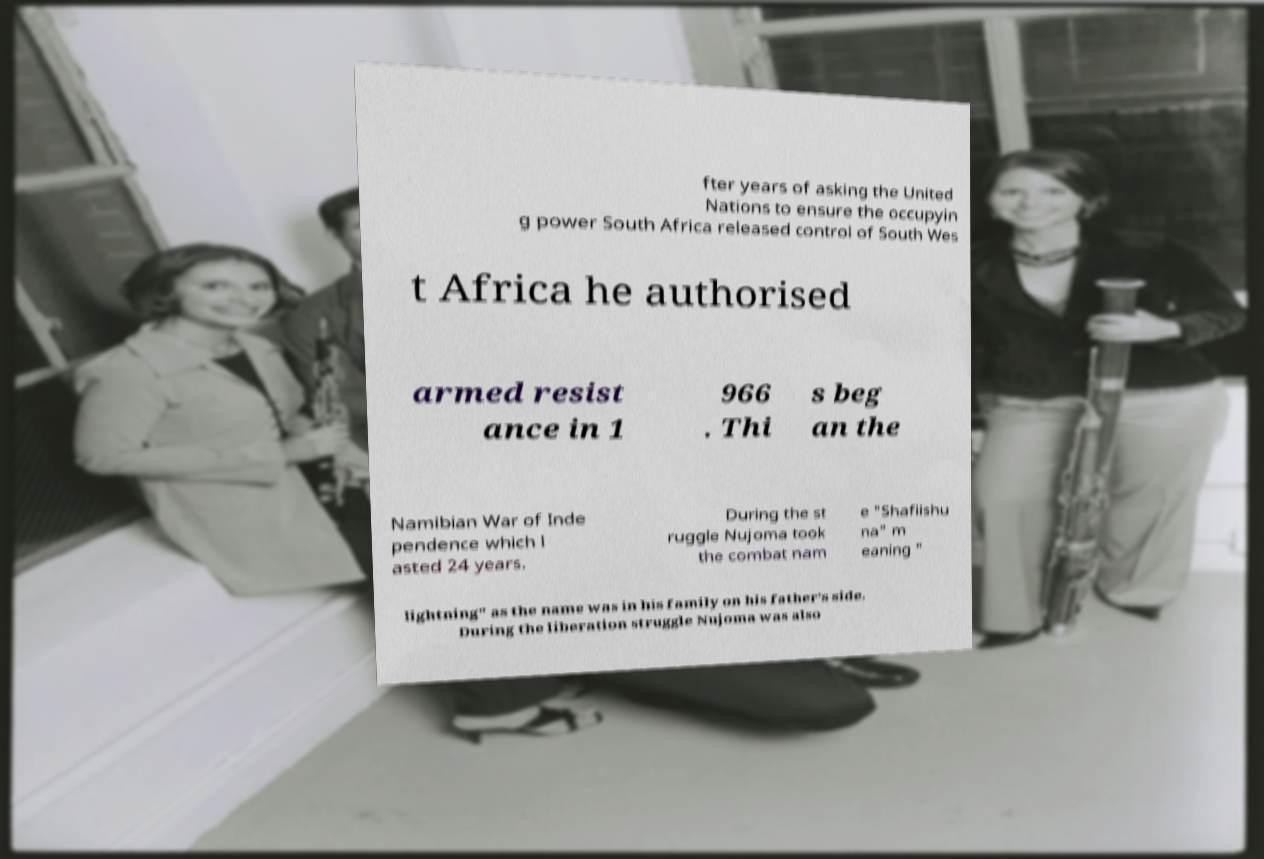For documentation purposes, I need the text within this image transcribed. Could you provide that? fter years of asking the United Nations to ensure the occupyin g power South Africa released control of South Wes t Africa he authorised armed resist ance in 1 966 . Thi s beg an the Namibian War of Inde pendence which l asted 24 years. During the st ruggle Nujoma took the combat nam e "Shafiishu na" m eaning " lightning" as the name was in his family on his father's side. During the liberation struggle Nujoma was also 